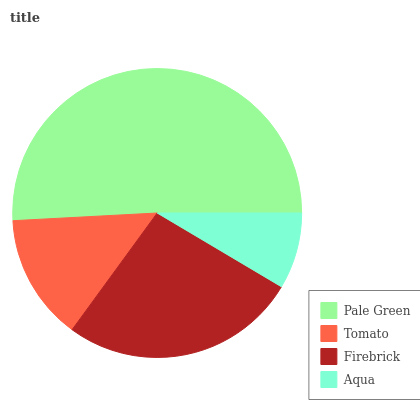Is Aqua the minimum?
Answer yes or no. Yes. Is Pale Green the maximum?
Answer yes or no. Yes. Is Tomato the minimum?
Answer yes or no. No. Is Tomato the maximum?
Answer yes or no. No. Is Pale Green greater than Tomato?
Answer yes or no. Yes. Is Tomato less than Pale Green?
Answer yes or no. Yes. Is Tomato greater than Pale Green?
Answer yes or no. No. Is Pale Green less than Tomato?
Answer yes or no. No. Is Firebrick the high median?
Answer yes or no. Yes. Is Tomato the low median?
Answer yes or no. Yes. Is Tomato the high median?
Answer yes or no. No. Is Pale Green the low median?
Answer yes or no. No. 